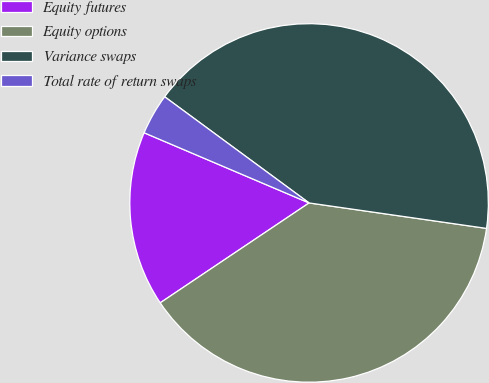Convert chart. <chart><loc_0><loc_0><loc_500><loc_500><pie_chart><fcel>Equity futures<fcel>Equity options<fcel>Variance swaps<fcel>Total rate of return swaps<nl><fcel>15.81%<fcel>38.33%<fcel>42.18%<fcel>3.69%<nl></chart> 